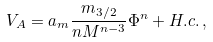Convert formula to latex. <formula><loc_0><loc_0><loc_500><loc_500>V _ { A } = a _ { m } \frac { m _ { 3 / 2 } } { n M ^ { n - 3 } } \Phi ^ { n } + H . c . \, ,</formula> 